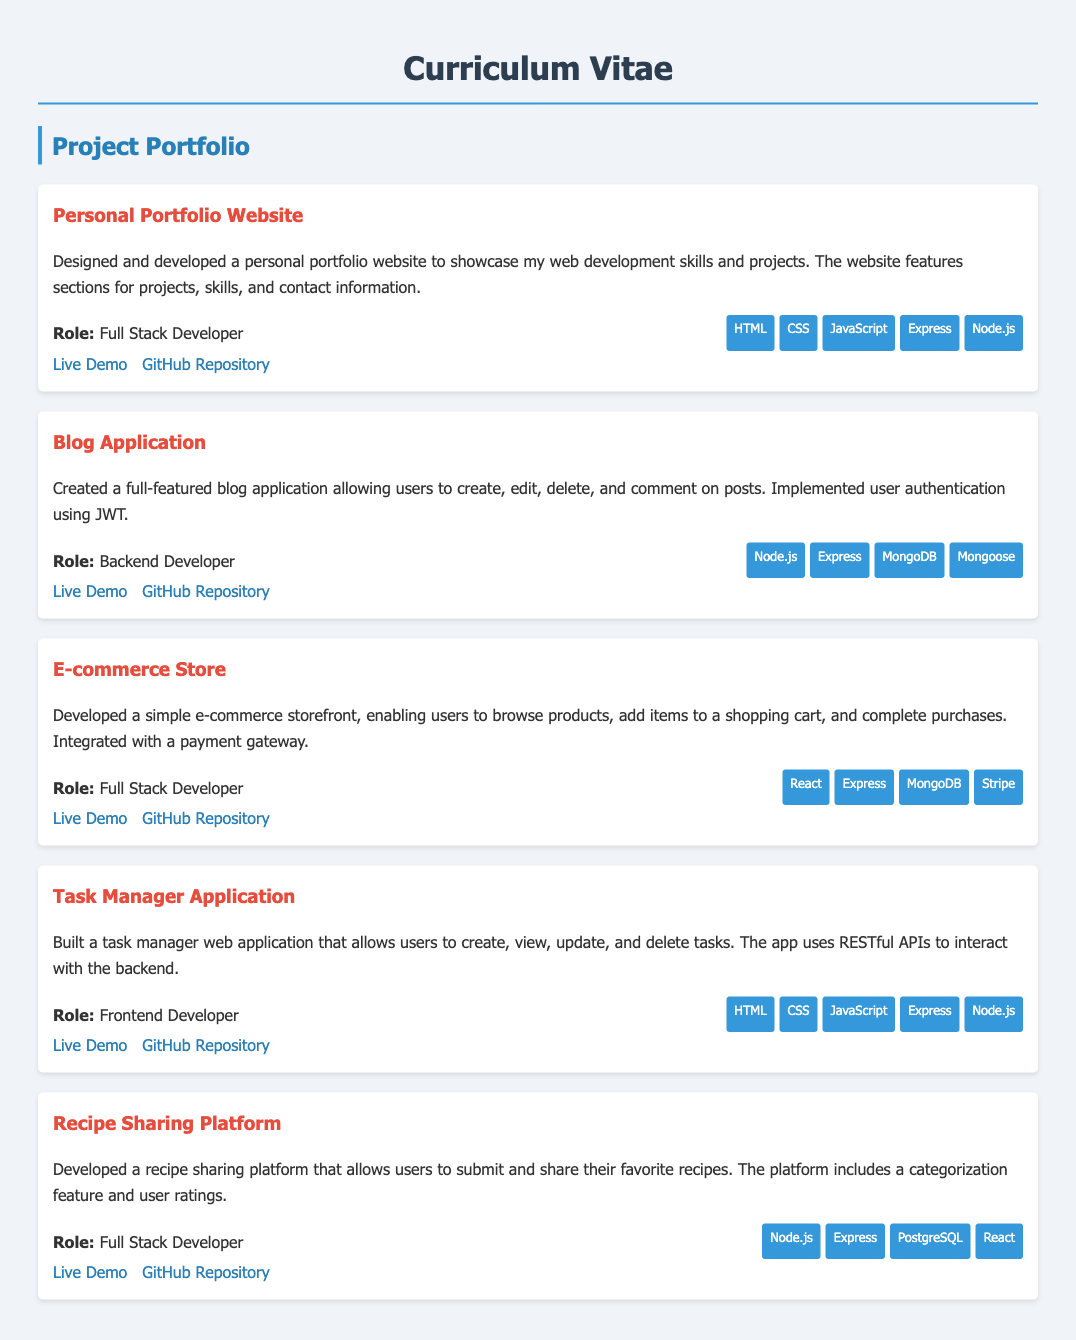What is the title of the first project? The first project listed is titled "Personal Portfolio Website."
Answer: Personal Portfolio Website What role did you have in the Blog Application project? In the Blog Application project, the role specified is "Backend Developer."
Answer: Backend Developer Which database technology was used in the Recipe Sharing Platform? The Recipe Sharing Platform uses "PostgreSQL" as the database technology.
Answer: PostgreSQL How many projects are listed in the project portfolio? The document lists a total of five projects in the project portfolio.
Answer: Five What is one technology used in both the E-commerce Store and the Recipe Sharing Platform? "Express" is used in both the E-commerce Store and the Recipe Sharing Platform.
Answer: Express What is the live demo link for the Task Manager Application? The live demo link provided for the Task Manager Application is "https://mytaskmanager.com."
Answer: https://mytaskmanager.com What feature does the Blog Application have for user interaction? The Blog Application allows users to "create, edit, delete, and comment on posts."
Answer: create, edit, delete, and comment on posts Which project includes payment integration? The project titled "E-commerce Store" includes payment integration.
Answer: E-commerce Store 